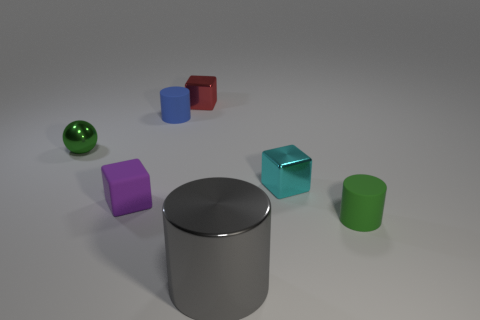What size is the purple object?
Give a very brief answer. Small. How many other things are the same color as the metal sphere?
Make the answer very short. 1. There is a blue rubber thing to the left of the tiny red thing; is it the same shape as the big metallic thing?
Ensure brevity in your answer.  Yes. There is another big thing that is the same shape as the green matte thing; what is its color?
Your response must be concise. Gray. There is a metallic thing that is the same shape as the blue matte object; what size is it?
Offer a very short reply. Large. What is the material of the small object that is both in front of the green metal ball and on the left side of the tiny blue cylinder?
Offer a terse response. Rubber. Does the small matte object that is right of the tiny red object have the same color as the tiny sphere?
Keep it short and to the point. Yes. There is a metallic ball; is its color the same as the tiny cylinder that is to the right of the red object?
Keep it short and to the point. Yes. There is a blue matte cylinder; are there any gray cylinders on the right side of it?
Make the answer very short. Yes. Is the material of the cyan object the same as the small ball?
Make the answer very short. Yes. 